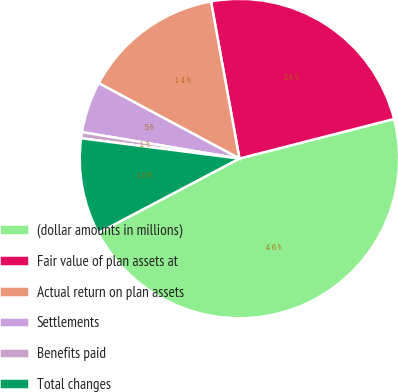<chart> <loc_0><loc_0><loc_500><loc_500><pie_chart><fcel>(dollar amounts in millions)<fcel>Fair value of plan assets at<fcel>Actual return on plan assets<fcel>Settlements<fcel>Benefits paid<fcel>Total changes<nl><fcel>46.27%<fcel>23.86%<fcel>14.32%<fcel>5.18%<fcel>0.62%<fcel>9.75%<nl></chart> 